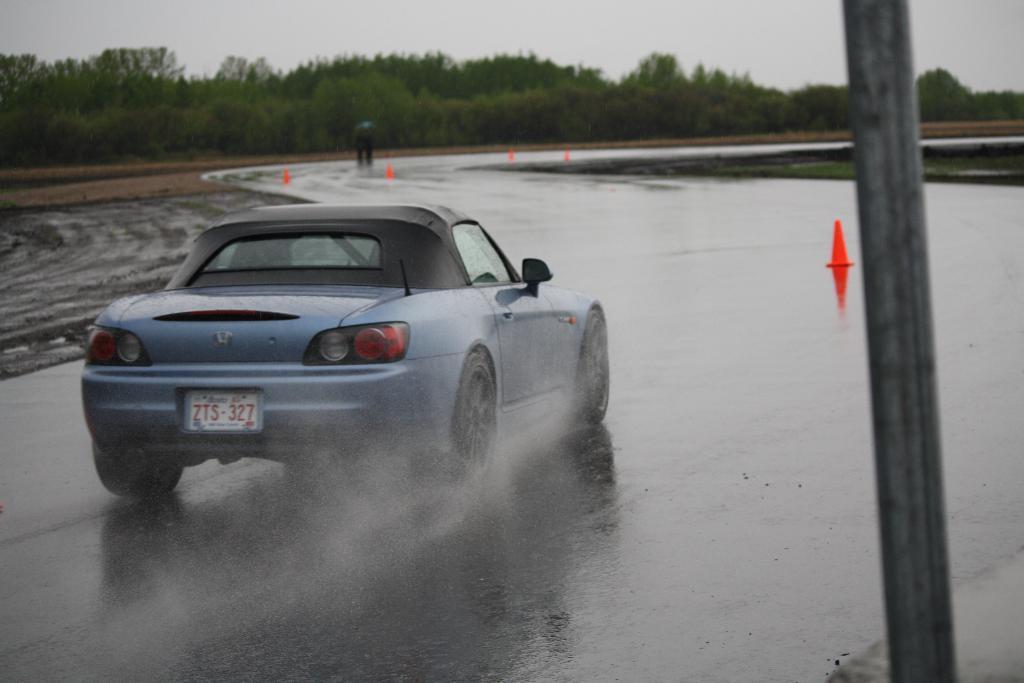In one or two sentences, can you explain what this image depicts? In this image we can see the car passing on the wet road. We can also see a pole, safety cones and also the person in the background. We can also see the trees. Sky is also visible. 